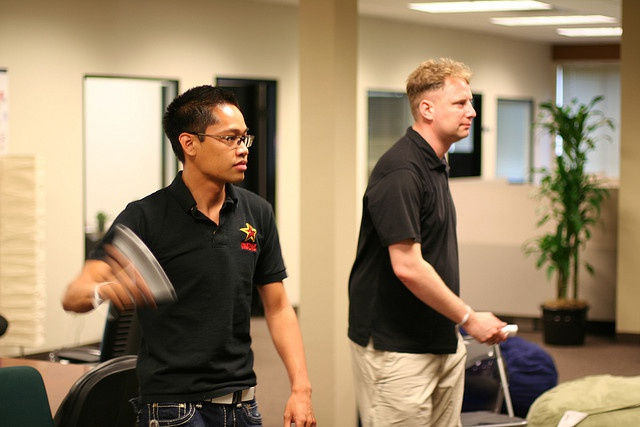Describe the objects in this image and their specific colors. I can see people in olive, black, tan, brown, and maroon tones, people in olive, black, tan, and maroon tones, potted plant in olive, black, darkgray, and tan tones, chair in olive, black, and gray tones, and chair in olive, black, and gray tones in this image. 